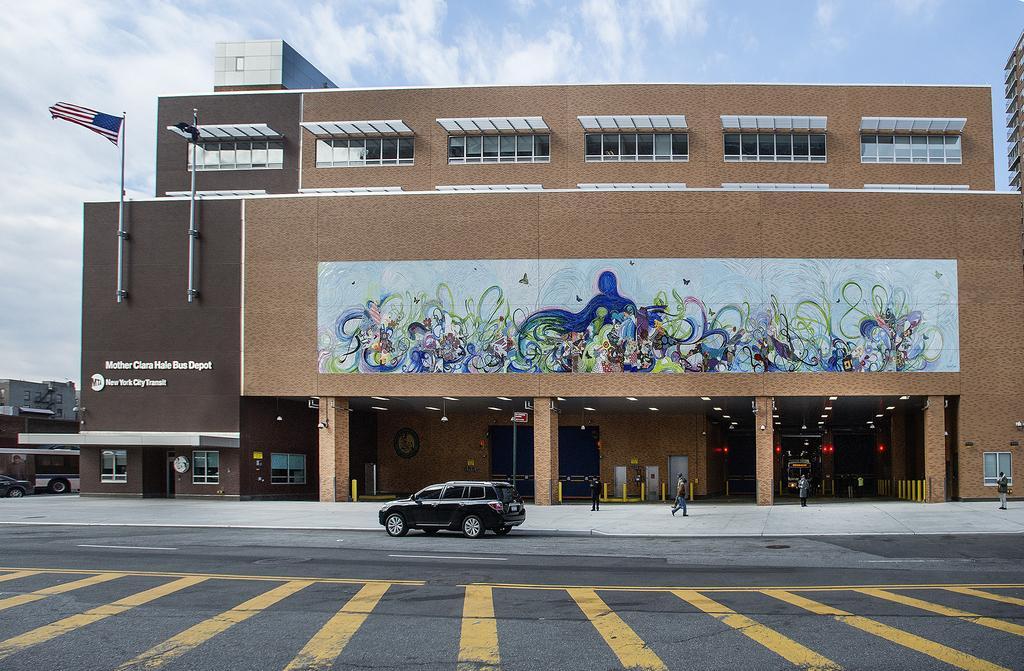Please provide a concise description of this image. In the middle a car is there on a road which is in black color and this is a very big building, at the top it's a sunny sky. 